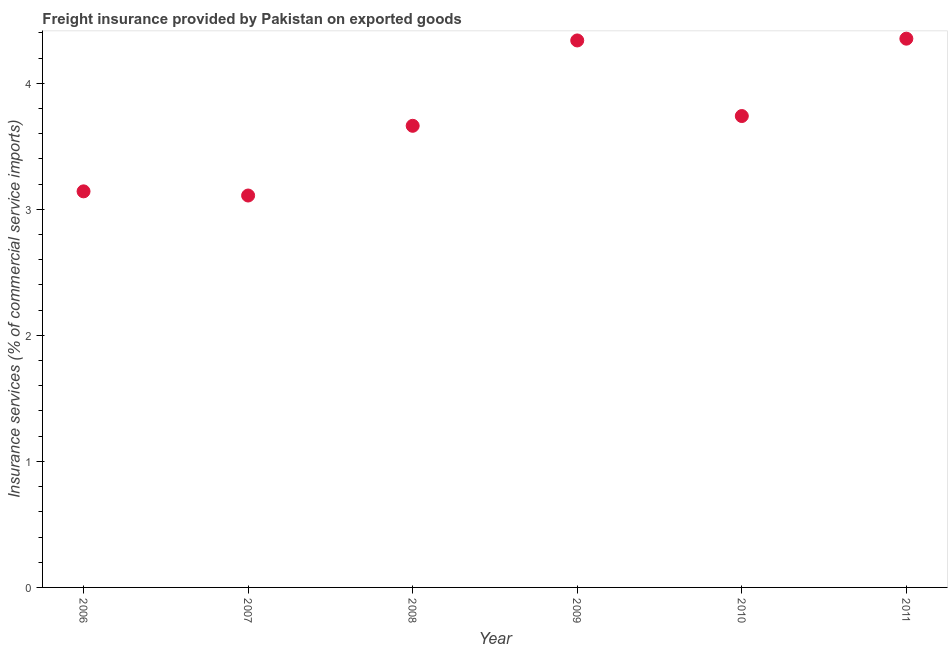What is the freight insurance in 2009?
Give a very brief answer. 4.34. Across all years, what is the maximum freight insurance?
Your answer should be very brief. 4.35. Across all years, what is the minimum freight insurance?
Make the answer very short. 3.11. In which year was the freight insurance minimum?
Your answer should be compact. 2007. What is the sum of the freight insurance?
Give a very brief answer. 22.35. What is the difference between the freight insurance in 2007 and 2010?
Your answer should be very brief. -0.63. What is the average freight insurance per year?
Your answer should be compact. 3.73. What is the median freight insurance?
Offer a very short reply. 3.7. What is the ratio of the freight insurance in 2007 to that in 2008?
Offer a terse response. 0.85. What is the difference between the highest and the second highest freight insurance?
Give a very brief answer. 0.01. Is the sum of the freight insurance in 2007 and 2010 greater than the maximum freight insurance across all years?
Provide a succinct answer. Yes. What is the difference between the highest and the lowest freight insurance?
Keep it short and to the point. 1.24. In how many years, is the freight insurance greater than the average freight insurance taken over all years?
Provide a short and direct response. 3. Does the freight insurance monotonically increase over the years?
Your answer should be very brief. No. How many years are there in the graph?
Keep it short and to the point. 6. What is the title of the graph?
Ensure brevity in your answer.  Freight insurance provided by Pakistan on exported goods . What is the label or title of the Y-axis?
Make the answer very short. Insurance services (% of commercial service imports). What is the Insurance services (% of commercial service imports) in 2006?
Keep it short and to the point. 3.14. What is the Insurance services (% of commercial service imports) in 2007?
Give a very brief answer. 3.11. What is the Insurance services (% of commercial service imports) in 2008?
Give a very brief answer. 3.66. What is the Insurance services (% of commercial service imports) in 2009?
Your answer should be compact. 4.34. What is the Insurance services (% of commercial service imports) in 2010?
Offer a terse response. 3.74. What is the Insurance services (% of commercial service imports) in 2011?
Provide a succinct answer. 4.35. What is the difference between the Insurance services (% of commercial service imports) in 2006 and 2007?
Your response must be concise. 0.03. What is the difference between the Insurance services (% of commercial service imports) in 2006 and 2008?
Ensure brevity in your answer.  -0.52. What is the difference between the Insurance services (% of commercial service imports) in 2006 and 2009?
Provide a succinct answer. -1.2. What is the difference between the Insurance services (% of commercial service imports) in 2006 and 2010?
Ensure brevity in your answer.  -0.6. What is the difference between the Insurance services (% of commercial service imports) in 2006 and 2011?
Your response must be concise. -1.21. What is the difference between the Insurance services (% of commercial service imports) in 2007 and 2008?
Your answer should be very brief. -0.55. What is the difference between the Insurance services (% of commercial service imports) in 2007 and 2009?
Give a very brief answer. -1.23. What is the difference between the Insurance services (% of commercial service imports) in 2007 and 2010?
Your answer should be compact. -0.63. What is the difference between the Insurance services (% of commercial service imports) in 2007 and 2011?
Ensure brevity in your answer.  -1.24. What is the difference between the Insurance services (% of commercial service imports) in 2008 and 2009?
Make the answer very short. -0.68. What is the difference between the Insurance services (% of commercial service imports) in 2008 and 2010?
Your response must be concise. -0.08. What is the difference between the Insurance services (% of commercial service imports) in 2008 and 2011?
Provide a short and direct response. -0.69. What is the difference between the Insurance services (% of commercial service imports) in 2009 and 2010?
Provide a succinct answer. 0.6. What is the difference between the Insurance services (% of commercial service imports) in 2009 and 2011?
Provide a succinct answer. -0.01. What is the difference between the Insurance services (% of commercial service imports) in 2010 and 2011?
Your answer should be compact. -0.61. What is the ratio of the Insurance services (% of commercial service imports) in 2006 to that in 2008?
Offer a terse response. 0.86. What is the ratio of the Insurance services (% of commercial service imports) in 2006 to that in 2009?
Make the answer very short. 0.72. What is the ratio of the Insurance services (% of commercial service imports) in 2006 to that in 2010?
Provide a short and direct response. 0.84. What is the ratio of the Insurance services (% of commercial service imports) in 2006 to that in 2011?
Offer a terse response. 0.72. What is the ratio of the Insurance services (% of commercial service imports) in 2007 to that in 2008?
Provide a short and direct response. 0.85. What is the ratio of the Insurance services (% of commercial service imports) in 2007 to that in 2009?
Offer a very short reply. 0.72. What is the ratio of the Insurance services (% of commercial service imports) in 2007 to that in 2010?
Your answer should be compact. 0.83. What is the ratio of the Insurance services (% of commercial service imports) in 2007 to that in 2011?
Give a very brief answer. 0.71. What is the ratio of the Insurance services (% of commercial service imports) in 2008 to that in 2009?
Provide a short and direct response. 0.84. What is the ratio of the Insurance services (% of commercial service imports) in 2008 to that in 2011?
Ensure brevity in your answer.  0.84. What is the ratio of the Insurance services (% of commercial service imports) in 2009 to that in 2010?
Your response must be concise. 1.16. What is the ratio of the Insurance services (% of commercial service imports) in 2009 to that in 2011?
Your response must be concise. 1. What is the ratio of the Insurance services (% of commercial service imports) in 2010 to that in 2011?
Your answer should be compact. 0.86. 